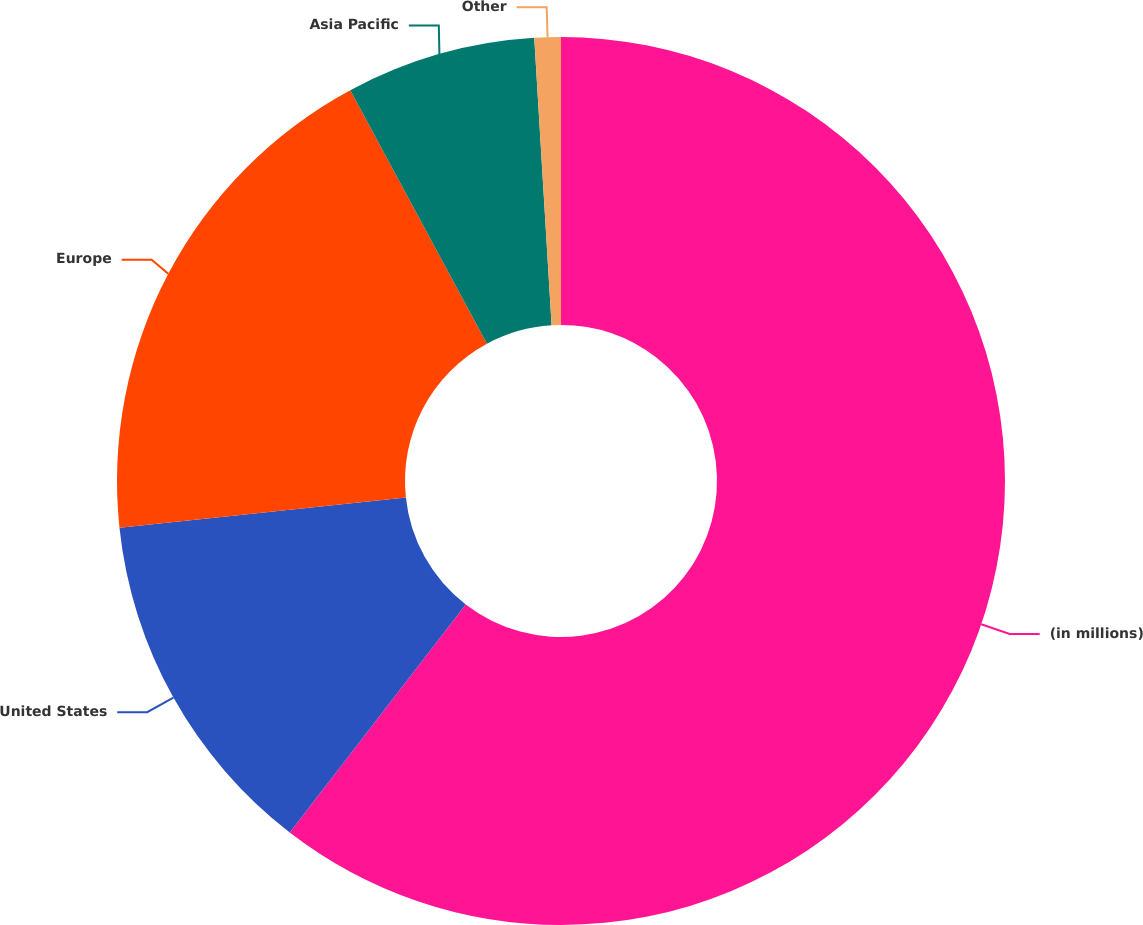Convert chart. <chart><loc_0><loc_0><loc_500><loc_500><pie_chart><fcel>(in millions)<fcel>United States<fcel>Europe<fcel>Asia Pacific<fcel>Other<nl><fcel>60.46%<fcel>12.86%<fcel>18.81%<fcel>6.91%<fcel>0.96%<nl></chart> 